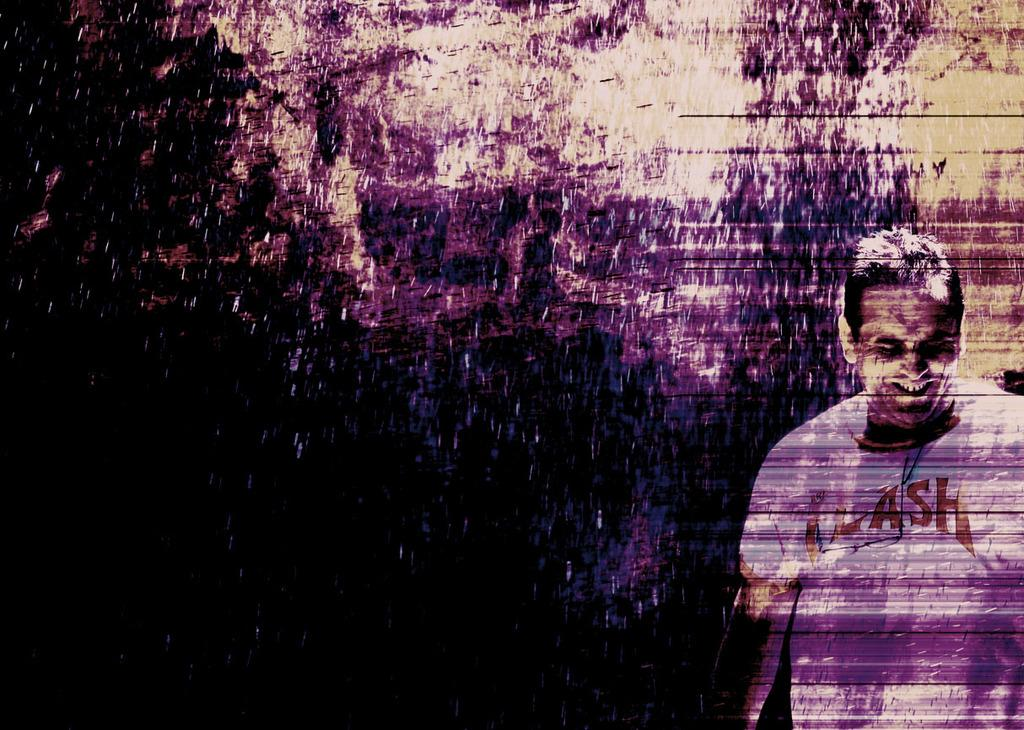What is the main subject of the image? The main subject of the image is a man. What is the man doing in the image? The man is standing in the image. What is the man's facial expression in the image? The man is smiling in the image. What is the man wearing in the image? The man is wearing a white t-shirt in the image. What can be observed about the background of the image? The background of the image is dark. How many sticks are visible in the man's hand in the image? There are no sticks visible in the man's hand in the image. What type of eggs can be seen in the background of the image? There are no eggs present in the image. 